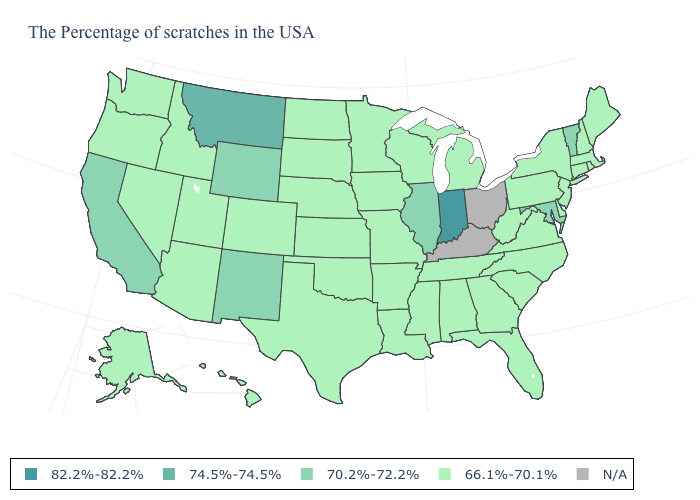Is the legend a continuous bar?
Write a very short answer. No. What is the value of Illinois?
Quick response, please. 70.2%-72.2%. What is the value of Alaska?
Keep it brief. 66.1%-70.1%. What is the highest value in the USA?
Be succinct. 82.2%-82.2%. Name the states that have a value in the range 74.5%-74.5%?
Quick response, please. Montana. How many symbols are there in the legend?
Answer briefly. 5. Does the first symbol in the legend represent the smallest category?
Be succinct. No. Does Indiana have the lowest value in the MidWest?
Give a very brief answer. No. What is the value of West Virginia?
Answer briefly. 66.1%-70.1%. What is the value of South Dakota?
Give a very brief answer. 66.1%-70.1%. Does Delaware have the lowest value in the South?
Keep it brief. Yes. What is the value of Alabama?
Concise answer only. 66.1%-70.1%. Does the map have missing data?
Answer briefly. Yes. What is the value of Colorado?
Answer briefly. 66.1%-70.1%. What is the value of Missouri?
Concise answer only. 66.1%-70.1%. 